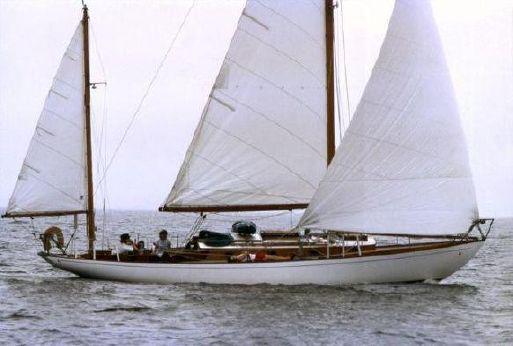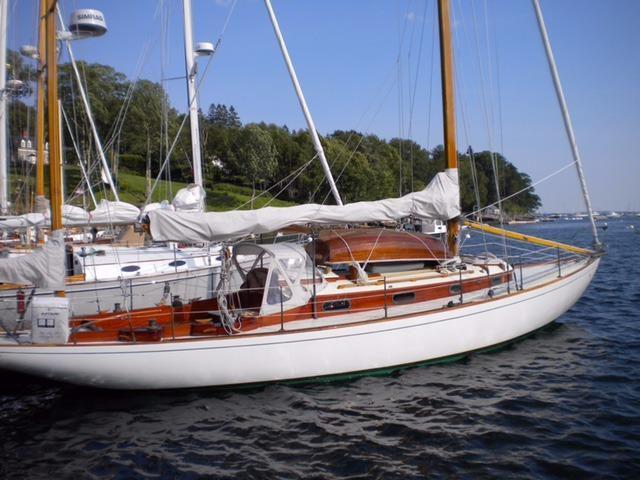The first image is the image on the left, the second image is the image on the right. For the images displayed, is the sentence "The boat in one image has an unfurled white sail." factually correct? Answer yes or no. Yes. The first image is the image on the left, the second image is the image on the right. Assess this claim about the two images: "The sails on both of the sailboats are furled.". Correct or not? Answer yes or no. No. 